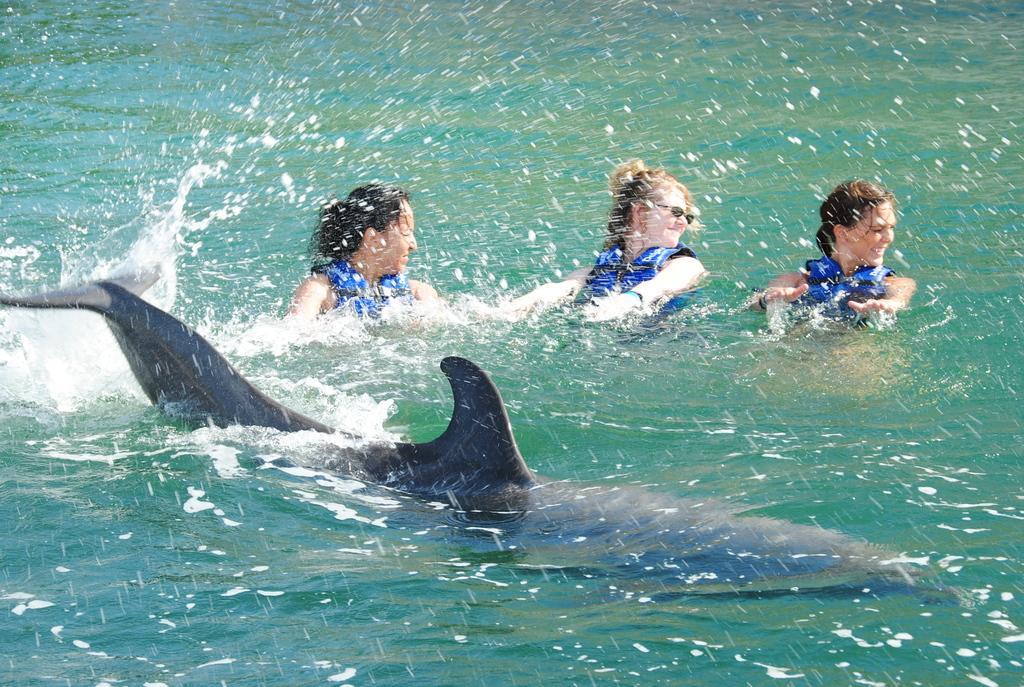Please provide a concise description of this image. In this picture I can see there is a dolphin swimming in the water and there are three women wearing blue life jackets and they are looking at right side. 